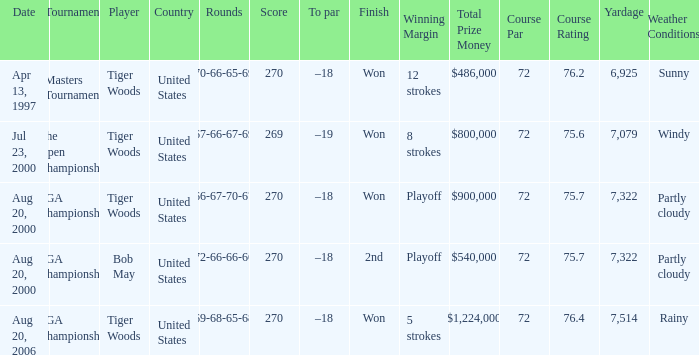What is the worst (highest) score? 270.0. Parse the table in full. {'header': ['Date', 'Tournament', 'Player', 'Country', 'Rounds', 'Score', 'To par', 'Finish', 'Winning Margin', 'Total Prize Money', 'Course Par', 'Course Rating', 'Yardage', 'Weather Conditions '], 'rows': [['Apr 13, 1997', 'Masters Tournament', 'Tiger Woods', 'United States', '70-66-65-69', '270', '–18', 'Won', '12 strokes', '$486,000', '72', '76.2', '6,925', 'Sunny'], ['Jul 23, 2000', 'The Open Championship', 'Tiger Woods', 'United States', '67-66-67-69', '269', '–19', 'Won', '8 strokes', '$800,000', '72', '75.6', '7,079', 'Windy'], ['Aug 20, 2000', 'PGA Championship', 'Tiger Woods', 'United States', '66-67-70-67', '270', '–18', 'Won', 'Playoff', '$900,000', '72', '75.7', '7,322', 'Partly cloudy'], ['Aug 20, 2000', 'PGA Championship', 'Bob May', 'United States', '72-66-66-66', '270', '–18', '2nd', 'Playoff', '$540,000', '72', '75.7', '7,322', 'Partly cloudy '], ['Aug 20, 2006', 'PGA Championship', 'Tiger Woods', 'United States', '69-68-65-68', '270', '–18', 'Won', '5 strokes', '$1,224,000', '72', '76.4', '7,514', 'Rainy']]} 